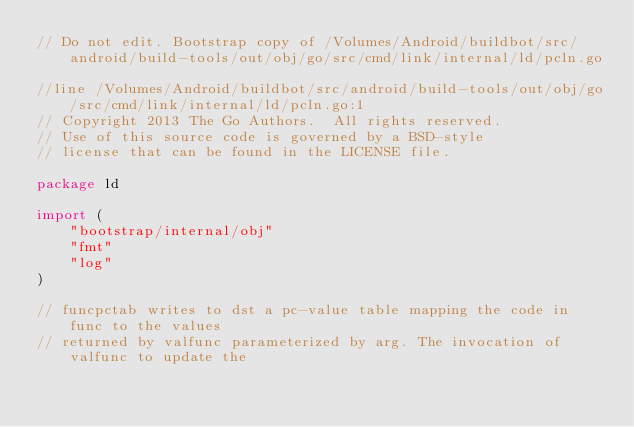Convert code to text. <code><loc_0><loc_0><loc_500><loc_500><_Go_>// Do not edit. Bootstrap copy of /Volumes/Android/buildbot/src/android/build-tools/out/obj/go/src/cmd/link/internal/ld/pcln.go

//line /Volumes/Android/buildbot/src/android/build-tools/out/obj/go/src/cmd/link/internal/ld/pcln.go:1
// Copyright 2013 The Go Authors.  All rights reserved.
// Use of this source code is governed by a BSD-style
// license that can be found in the LICENSE file.

package ld

import (
	"bootstrap/internal/obj"
	"fmt"
	"log"
)

// funcpctab writes to dst a pc-value table mapping the code in func to the values
// returned by valfunc parameterized by arg. The invocation of valfunc to update the</code> 